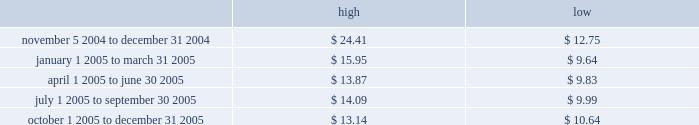Part ii price range our common stock commenced trading on the nasdaq national market under the symbol 201cmktx 201d on november 5 , 2004 .
Prior to that date , there was no public market for our common stock .
The high and low bid information for our common stock , as reported by nasdaq , was as follows : on march 8 , 2006 , the last reported closing price of our common stock on the nasdaq national market was $ 12.59 .
Holders there were approximately 114 holders of record of our common stock as of march 8 , 2006 .
Dividend policy we have not declared or paid any cash dividends on our capital stock since our inception .
We intend to retain future earnings to finance the operation and expansion of our business and do not anticipate paying any cash dividends in the foreseeable future .
In the event we decide to declare dividends on our common stock in the future , such declaration will be subject to the discretion of our board of directors .
Our board may take into account such matters as general business conditions , our financial results , capital requirements , contractual , legal , and regulatory restrictions on the payment of dividends by us to our stockholders or by our subsidiaries to us and any such other factors as our board may deem relevant .
Use of proceeds on november 4 , 2004 , the registration statement relating to our initial public offering ( no .
333-112718 ) was declared effective .
We received net proceeds from the sale of the shares of our common stock in the offering of $ 53.9 million , at an initial public offering price of $ 11.00 per share , after deducting underwriting discounts and commissions and estimated offering expenses .
Except for salaries , and reimbursements for travel expenses and other out-of -pocket costs incurred in the ordinary course of business , none of the proceeds from the offering have been paid by us , directly or indirectly , to any of our directors or officers or any of their associates , or to any persons owning ten percent or more of our outstanding stock or to any of our affiliates .
We have invested the proceeds from the offering in cash and cash equivalents and short-term marketable securities .
Item 5 .
Market for registrant 2019s common equity , related stockholder matters and issuer purchases of equity securities .

According to the above listed holders of common stock , what was the market share of mktx common stock on march 8 , 2006? 
Computations: (12.59 * 114)
Answer: 1435.26. 